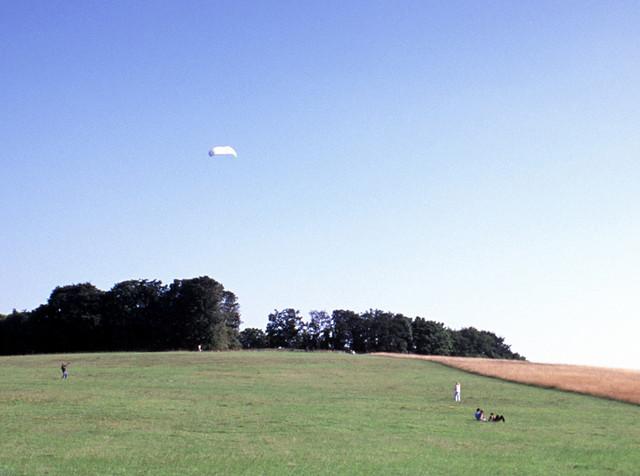What type of land is next to the grass?
Be succinct. Sand. Is the sky completely clear?
Keep it brief. Yes. What color is the kite?
Quick response, please. White. Is it sunny?
Keep it brief. Yes. What is flying?
Short answer required. Kite. 